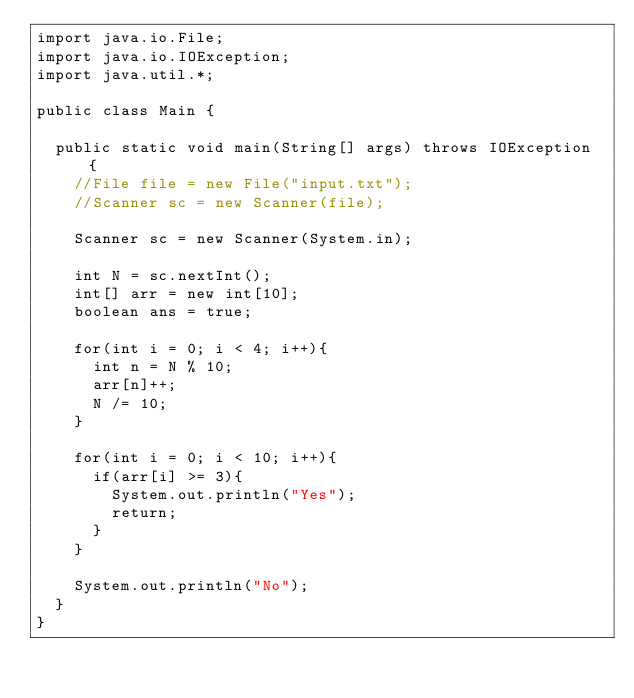Convert code to text. <code><loc_0><loc_0><loc_500><loc_500><_Java_>import java.io.File;
import java.io.IOException;
import java.util.*;
 
public class Main {
 
	public static void main(String[] args) throws IOException {
		//File file = new File("input.txt");
		//Scanner sc = new Scanner(file);
		
		Scanner sc = new Scanner(System.in);
		
		int N = sc.nextInt();
		int[] arr = new int[10];
		boolean ans = true;
		
		for(int i = 0; i < 4; i++){
			int n = N % 10;
			arr[n]++;
			N /= 10;
		}
		
		for(int i = 0; i < 10; i++){
			if(arr[i] >= 3){
				System.out.println("Yes");
				return;
			}
		}
		
		System.out.println("No");
	}
}</code> 